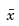Convert formula to latex. <formula><loc_0><loc_0><loc_500><loc_500>\bar { x }</formula> 